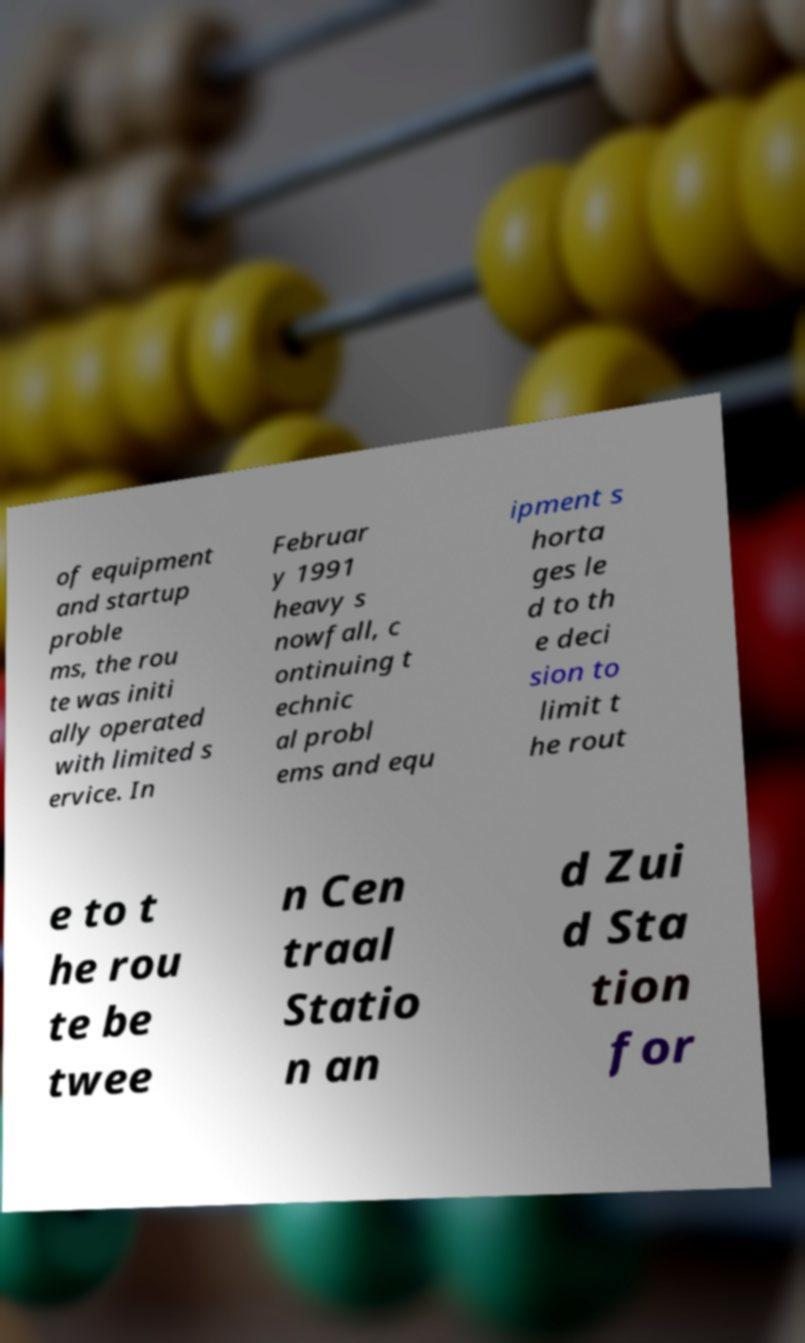There's text embedded in this image that I need extracted. Can you transcribe it verbatim? of equipment and startup proble ms, the rou te was initi ally operated with limited s ervice. In Februar y 1991 heavy s nowfall, c ontinuing t echnic al probl ems and equ ipment s horta ges le d to th e deci sion to limit t he rout e to t he rou te be twee n Cen traal Statio n an d Zui d Sta tion for 